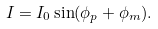Convert formula to latex. <formula><loc_0><loc_0><loc_500><loc_500>I = I _ { 0 } \sin ( \phi _ { p } + \phi _ { m } ) .</formula> 